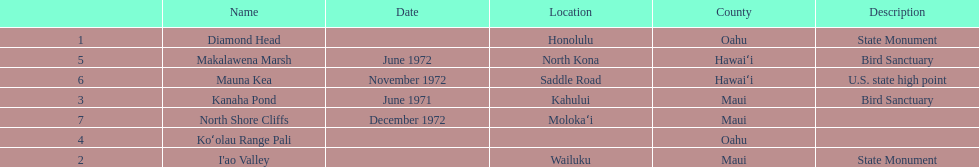What is the number of bird sanctuary landmarks? 2. Write the full table. {'header': ['', 'Name', 'Date', 'Location', 'County', 'Description'], 'rows': [['1', 'Diamond Head', '', 'Honolulu', 'Oahu', 'State Monument'], ['5', 'Makalawena Marsh', 'June 1972', 'North Kona', 'Hawaiʻi', 'Bird Sanctuary'], ['6', 'Mauna Kea', 'November 1972', 'Saddle Road', 'Hawaiʻi', 'U.S. state high point'], ['3', 'Kanaha Pond', 'June 1971', 'Kahului', 'Maui', 'Bird Sanctuary'], ['7', 'North Shore Cliffs', 'December 1972', 'Molokaʻi', 'Maui', ''], ['4', 'Koʻolau Range Pali', '', '', 'Oahu', ''], ['2', "I'ao Valley", '', 'Wailuku', 'Maui', 'State Monument']]} 